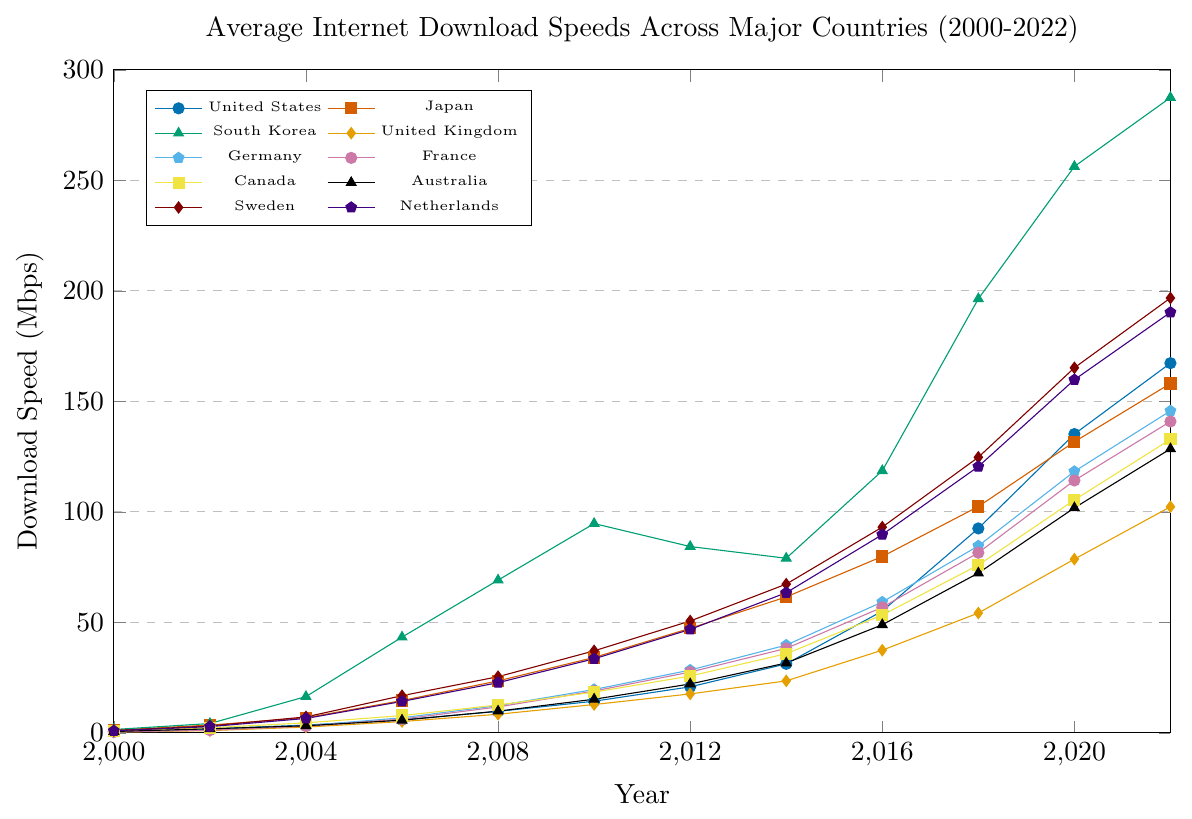What is the average download speed in 2022 for Germany and France? To get the average, sum up the download speeds of Germany (145.7 Mbps) and France (140.9 Mbps) in 2022, which equals 286.6. Then, divide this sum by 2, resulting in 143.3 Mbps.
Answer: 143.3 Mbps Which country had the highest download speed in 2010? By examining the figure, South Korea had the highest download speed in 2010, which is 94.7 Mbps.
Answer: South Korea Which country had the slowest growth in download speed from 2000 to 2022? Calculate the difference in download speeds from 2000 to 2022 for each country. The smallest difference indicates the slowest growth. The US increased by 166.8 Mbps, Japan by 156.9 Mbps, South Korea by 286 Mbps, the UK by 102 Mbps, Germany by 145.3 Mbps, France by 140.5 Mbps, Canada by 132 Mbps, Australia by 127.9 Mbps, Sweden by 195.8 Mbps, and the Netherlands by 189.4 Mbps. The UK, with an increase of 102 Mbps, had the slowest growth.
Answer: United Kingdom In which year did Japan's download speed surpass the 50 Mbps mark? Observe Japan's line in the figure. In 2012, Japan's download speed was 47.3 Mbps, and in 2014 it was 61.5 Mbps. Therefore, 2014 was the year when Japan's download speed surpassed 50 Mbps.
Answer: 2014 How many countries had download speeds exceeding 100 Mbps in 2016? Identify the countries with download speeds exceeding 100 Mbps in 2016 by analyzing the figure: South Korea (118.6 Mbps). Only one country had download speeds exceeding 100 Mbps in 2016.
Answer: 1 What is the difference in download speed between Sweden and Australia in 2018? Check the download speeds of Sweden and Australia in 2018. Sweden had 124.7 Mbps and Australia had 72.3 Mbps. The difference is 124.7 - 72.3 = 52.4 Mbps.
Answer: 52.4 Mbps Which country showed the highest increase in download speed between 2018 and 2020? Analyze the download speed differences for each country between 2018 and 2020: USA (92.5 to 135.2 = 42.7 Mbps), Japan (102.4 to 131.7 = 29.3 Mbps), South Korea (196.4 to 256.3 = 59.9 Mbps), UK (54.2 to 78.6 = 24.4 Mbps), Germany (84.6 to 118.3 = 33.7 Mbps), France (81.5 to 114.2 = 32.7 Mbps), Canada (75.9 to 105.4 = 29.5 Mbps), Australia (72.3 to 101.8 = 29.5 Mbps), Sweden (124.7 to 165.2 = 40.5 Mbps), Netherlands (120.5 to 159.8 = 39.3 Mbps). South Korea showed the highest increase of 59.9 Mbps.
Answer: South Korea 